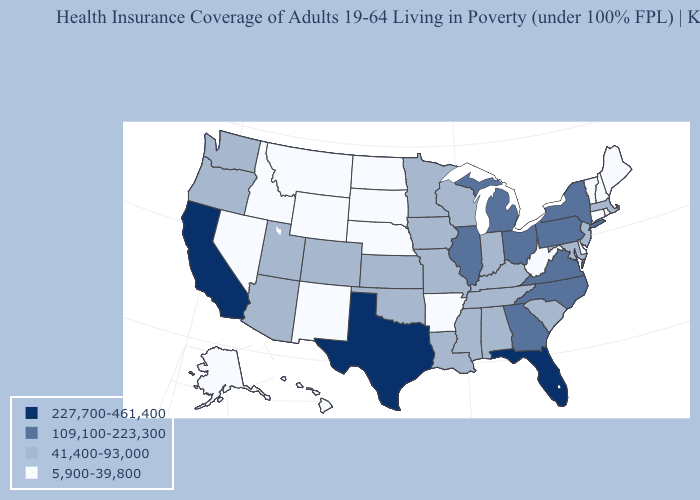Name the states that have a value in the range 5,900-39,800?
Short answer required. Alaska, Arkansas, Connecticut, Delaware, Hawaii, Idaho, Maine, Montana, Nebraska, Nevada, New Hampshire, New Mexico, North Dakota, Rhode Island, South Dakota, Vermont, West Virginia, Wyoming. What is the highest value in states that border Arkansas?
Concise answer only. 227,700-461,400. Name the states that have a value in the range 5,900-39,800?
Short answer required. Alaska, Arkansas, Connecticut, Delaware, Hawaii, Idaho, Maine, Montana, Nebraska, Nevada, New Hampshire, New Mexico, North Dakota, Rhode Island, South Dakota, Vermont, West Virginia, Wyoming. Does Wyoming have a lower value than Kansas?
Give a very brief answer. Yes. Among the states that border Kansas , does Colorado have the highest value?
Give a very brief answer. Yes. Does North Dakota have the same value as Nebraska?
Write a very short answer. Yes. Does the first symbol in the legend represent the smallest category?
Keep it brief. No. What is the lowest value in the West?
Give a very brief answer. 5,900-39,800. What is the value of Louisiana?
Short answer required. 41,400-93,000. Name the states that have a value in the range 41,400-93,000?
Write a very short answer. Alabama, Arizona, Colorado, Indiana, Iowa, Kansas, Kentucky, Louisiana, Maryland, Massachusetts, Minnesota, Mississippi, Missouri, New Jersey, Oklahoma, Oregon, South Carolina, Tennessee, Utah, Washington, Wisconsin. Does New Mexico have the lowest value in the USA?
Concise answer only. Yes. Name the states that have a value in the range 41,400-93,000?
Short answer required. Alabama, Arizona, Colorado, Indiana, Iowa, Kansas, Kentucky, Louisiana, Maryland, Massachusetts, Minnesota, Mississippi, Missouri, New Jersey, Oklahoma, Oregon, South Carolina, Tennessee, Utah, Washington, Wisconsin. Does the map have missing data?
Write a very short answer. No. Among the states that border Kansas , which have the lowest value?
Answer briefly. Nebraska. Among the states that border Idaho , does Wyoming have the lowest value?
Be succinct. Yes. 